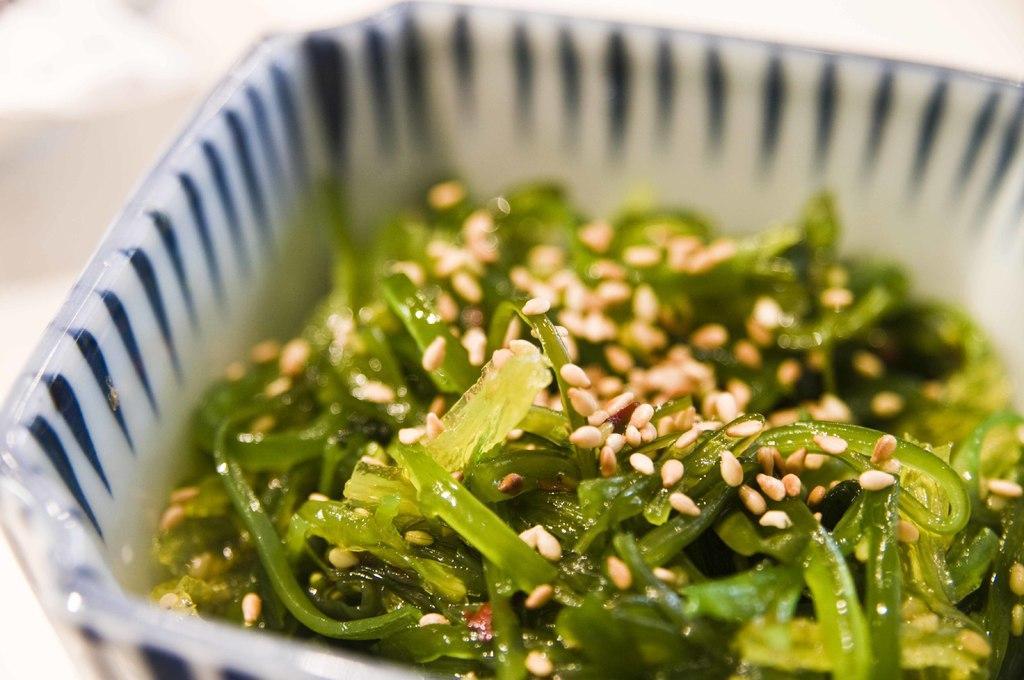Describe this image in one or two sentences. In this image we can see food items in a bowl. 